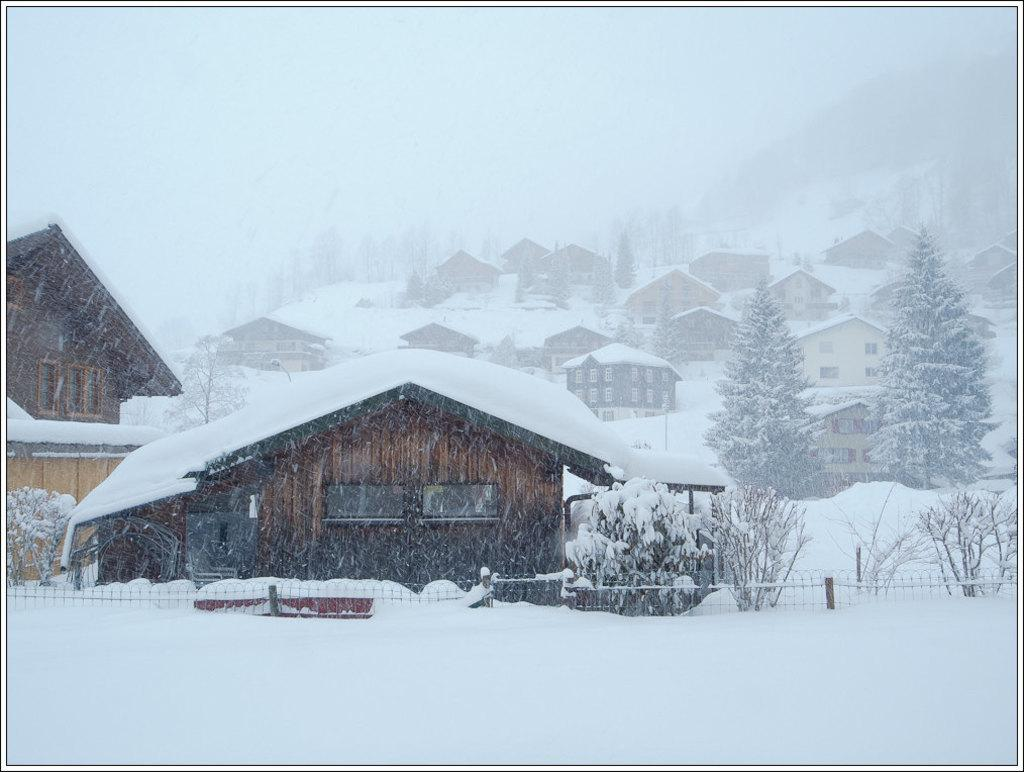What type of structures are present in the image? There are houses in the image. What type of vegetation can be seen in the image? There are plants and trees in the image. What is the weather like in the image? There is snow visible in the image, indicating a cold or wintery weather. What type of natural landmarks are present in the image? There are mountains in the image. What type of barrier is present in the image? There is fencing in the image. What is visible in the sky in the image? The sky is visible in the image. What type of soup is being served in the image? There is no soup present in the image. What news event is being reported in the image? There is no news event or news source present in the image. 